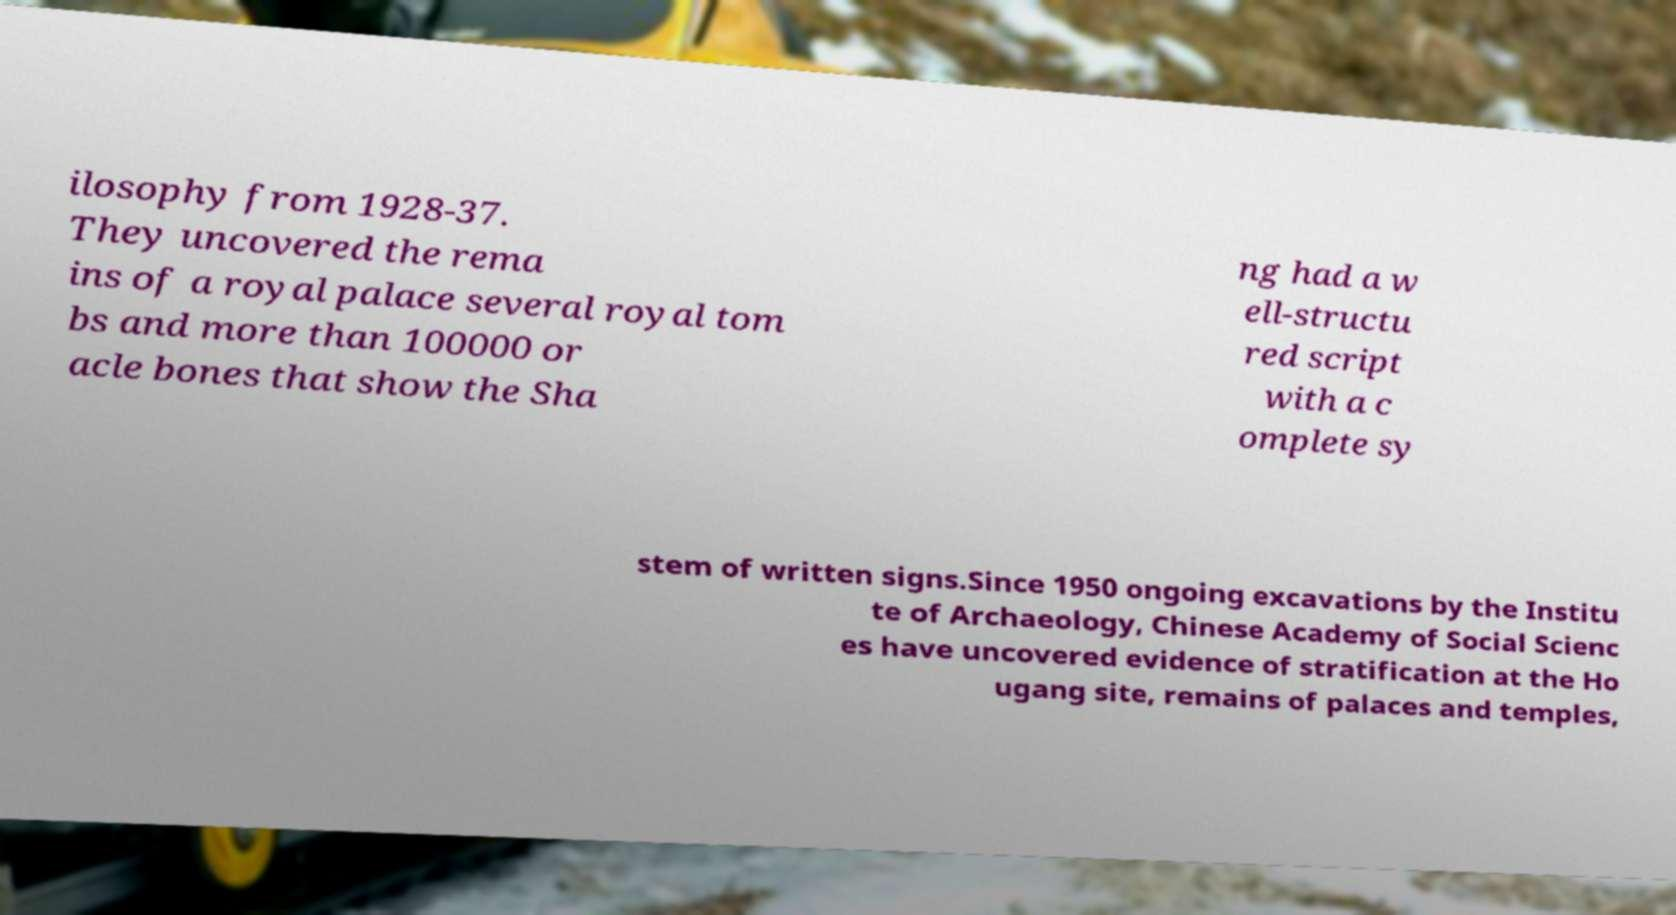Please identify and transcribe the text found in this image. ilosophy from 1928-37. They uncovered the rema ins of a royal palace several royal tom bs and more than 100000 or acle bones that show the Sha ng had a w ell-structu red script with a c omplete sy stem of written signs.Since 1950 ongoing excavations by the Institu te of Archaeology, Chinese Academy of Social Scienc es have uncovered evidence of stratification at the Ho ugang site, remains of palaces and temples, 